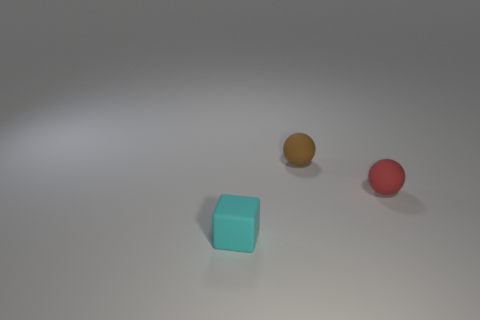Are there any other small cubes of the same color as the rubber cube?
Provide a succinct answer. No. What material is the tiny cyan block?
Your answer should be very brief. Rubber. How many things are either tiny blue things or matte balls?
Ensure brevity in your answer.  2. There is a red rubber ball in front of the small brown rubber sphere; what is its size?
Your answer should be very brief. Small. How many other objects are there of the same material as the brown thing?
Your answer should be compact. 2. Is there a rubber object that is behind the ball that is on the right side of the brown ball?
Keep it short and to the point. Yes. Are there any other things that have the same shape as the small cyan thing?
Keep it short and to the point. No. The other tiny thing that is the same shape as the tiny red matte thing is what color?
Your answer should be compact. Brown. How big is the cyan matte object?
Offer a terse response. Small. Is the number of matte things in front of the cyan thing less than the number of large green cubes?
Ensure brevity in your answer.  No. 